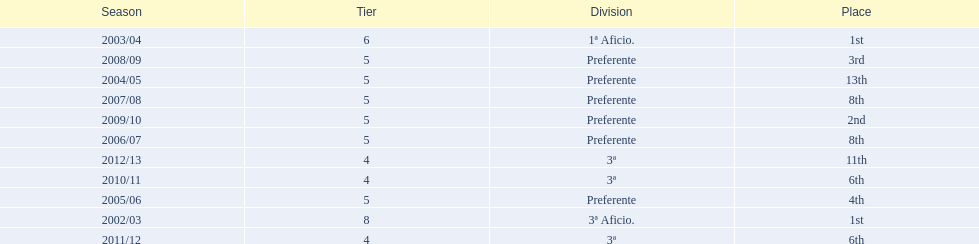Which seasons were played in tier four? 2010/11, 2011/12, 2012/13. Of these seasons, which resulted in 6th place? 2010/11, 2011/12. Which of the remaining happened last? 2011/12. 